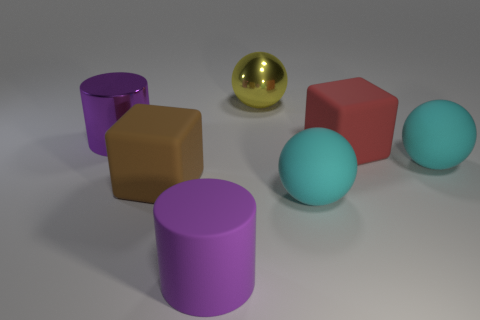There is a purple cylinder that is the same size as the purple rubber thing; what is it made of?
Provide a short and direct response. Metal. There is a thing that is left of the matte cylinder and behind the brown rubber block; what is its shape?
Your answer should be very brief. Cylinder. There is a shiny ball that is the same size as the rubber cylinder; what color is it?
Your response must be concise. Yellow. There is a purple cylinder on the left side of the rubber cylinder; does it have the same size as the matte block on the right side of the big yellow metal thing?
Your answer should be very brief. Yes. There is a purple cylinder that is behind the cyan ball on the left side of the cyan matte sphere to the right of the big red matte object; how big is it?
Keep it short and to the point. Large. There is a purple rubber object in front of the metallic object that is behind the purple metal object; what is its shape?
Your response must be concise. Cylinder. Is the color of the big matte cube that is right of the metal sphere the same as the big metallic cylinder?
Make the answer very short. No. There is a thing that is both on the left side of the rubber cylinder and in front of the big red rubber thing; what is its color?
Provide a short and direct response. Brown. Is there a red ball made of the same material as the red object?
Your response must be concise. No. What size is the red object?
Offer a very short reply. Large. 